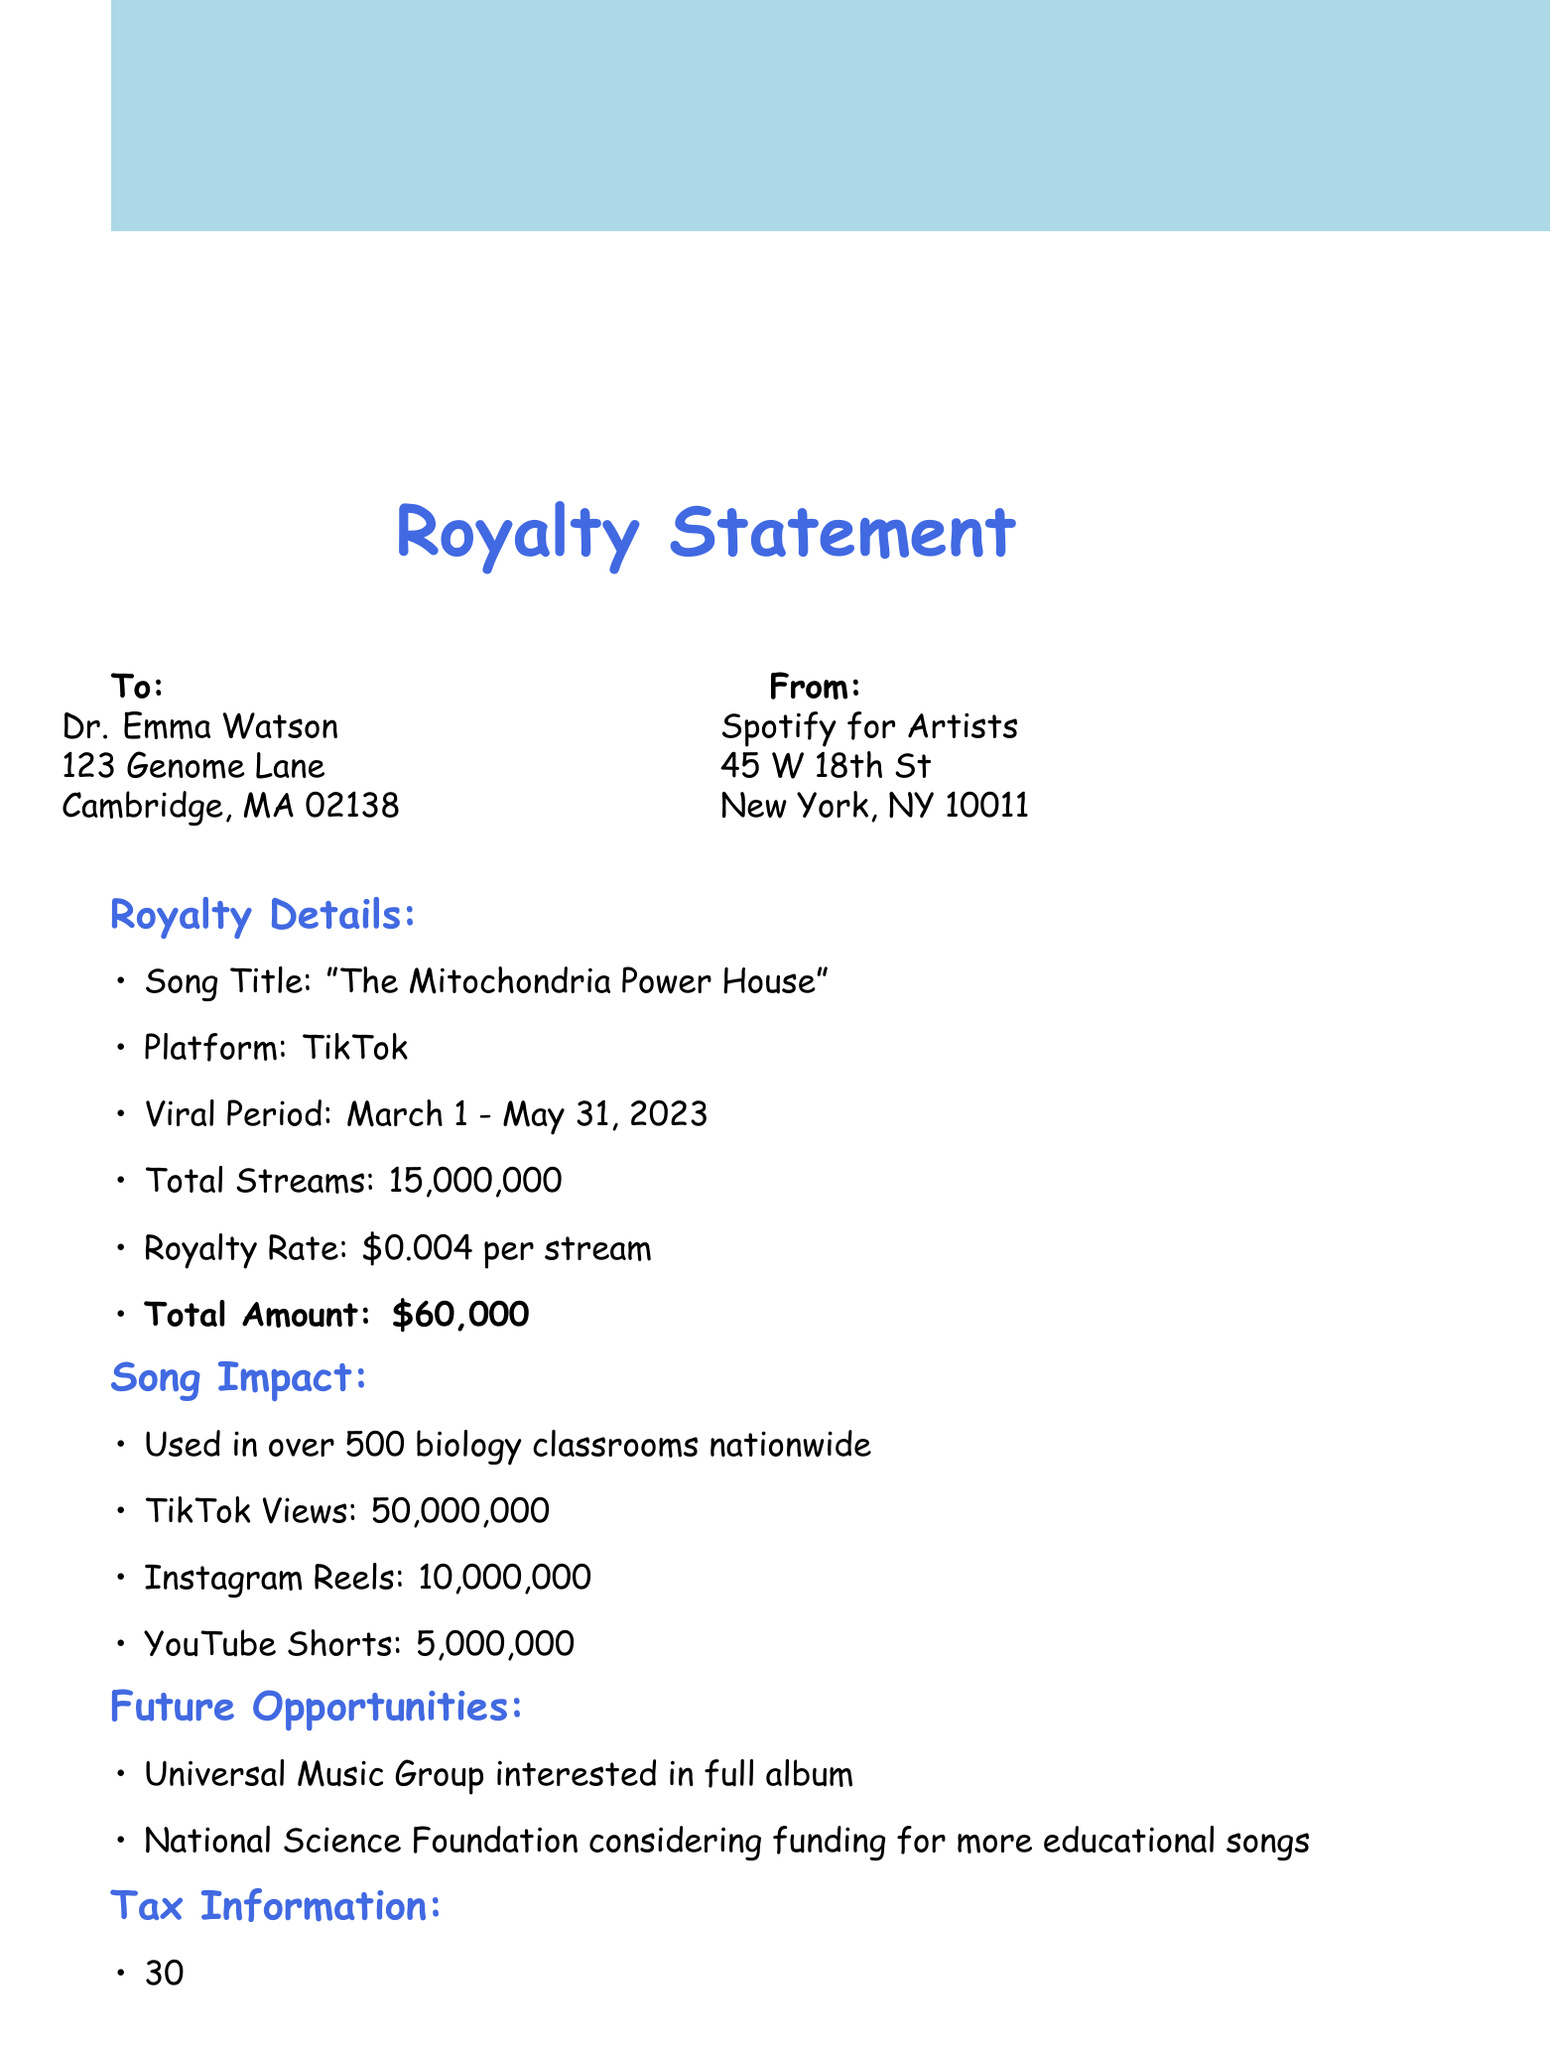What is the song title? The song title is explicitly stated in the royalty details section of the document.
Answer: The Mitochondria Power House What is the total amount of the royalty check? The total amount is clearly listed in the royalty details section of the document as the total for streams.
Answer: $60,000 How many total streams did the song have? The total number of streams is provided in the royalty details section.
Answer: 15,000,000 What percentage will be withheld for federal taxes? The tax withholding percentage is mentioned in the tax information section of the document.
Answer: 30% Which organization has expressed interest in a full album? The future opportunities section of the document indicates which record label is interested.
Answer: Universal Music Group How many biology classrooms used the song? The educational reach is specified in the song impact section of the document.
Answer: Over 500 biology classrooms nationwide When is the 1099 form expected to be sent? The date for sending the 1099 form is found in the tax information section.
Answer: By January 31, 2024 What is the expected payment date for the royalty check? The expected payment date can be found in the next steps section of the document.
Answer: Within 10 business days 